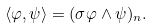<formula> <loc_0><loc_0><loc_500><loc_500>\langle \varphi , \psi \rangle = ( \sigma \varphi \wedge \psi ) _ { n } .</formula> 